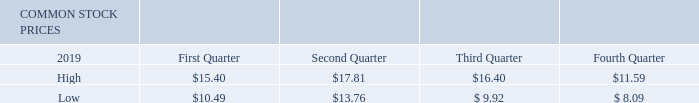Market for Registrant’s Common Equity, Related Stockholder Matters and Issuer Purchases of Equity Securities
ADTRAN’s common stock is traded on the NASDAQ Global Select Market under the symbol ADTN. As of February 19, 2020, ADTRAN had 163 stockholders of record and approximately 6,972 beneficial owners of shares held in street name. The following table shows the high and low closing prices per share for our common stock as reported by NASDAQ for the periods indicated.
What symbol is ADTRAN's common stock traded under on the NASDAQ Global Select Market? Adtn. What was the high closing price for common stock price in the First Quarter of 2019? $15.40. What was the high closing price for common stock price in the Fourth Quarter of 2019? $11.59. What was the difference between the high and low closing prices per share for common stock in the second quarter of 2019? $17.81-$13.76
Answer: 4.05. What was the average low closing price for 2019? ( $10.49 + $13.76 + $ 9.92 + $ 8.09 )/4
Answer: 10.57. What was the percentage change in the high closing price between the third and fourth quarter in 2019?
Answer scale should be: percent. ($11.59-$16.40)/$16.40
Answer: -29.33. 